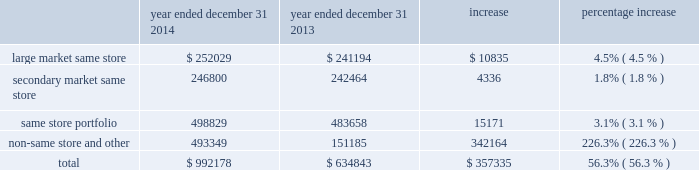Dispositions of depreciable real estate assets excluded from discontinued operations we recorded a gain on sale of depreciable assets excluded from discontinued operations of $ 190.0 million for the year ended december 31 , 2015 , an increase of approximately $ 147.3 million from the $ 42.6 million gain on sale of depreciable assets recorded for the year ended december 31 , 2014 .
The increase was primarily the result of increased disposition activity .
Dispositions increased from eight multifamily properties for the year ended december 31 , 2014 , to 21 multifamily properties for the year ended december 31 , 2015 .
Gain from real estate joint ventures we recorded a gain from real estate joint ventures of $ 6.0 million during the year ended december 31 , 2014 as opposed to no material gain or loss being recorded during the year ended december 31 , 2015 .
The decrease was primarily a result of recording a $ 3.4 million gain for the disposition of ansley village by mid-america multifamily fund ii , or fund ii , as well as a $ 2.8 million gain for the promote fee received from our fund ii partner during 2014 .
The promote fee was received as a result of maa achieving certain performance metrics in its management of the fund ii properties over the life of the joint venture .
There were no such gains recorded during the year ended december 31 , 2015 .
Discontinued operations we recorded a gain on sale of discontinued operations of $ 5.4 million for the year ended december 31 , 2014 .
We did not record a gain or loss on sale of discontinued operations during the year ended december 31 , 2015 , due to the adoption of asu 2014-08 , reporting discontinued operations and disclosures of disposals of components of an entity , which resulted in dispositions being included in the gain on sale of depreciable real estate assets excluded from discontinued operations and is discussed further below .
Net income attributable to noncontrolling interests net income attributable to noncontrolling interests for the year ended december 31 , 2015 was approximately $ 18.5 million , an increase of $ 10.2 million from the year ended december 31 , 2014 .
This increase is consistent with the increase to overall net income and is primarily a result of the items discussed above .
Net income attributable to maa primarily as a result of the items discussed above , net income attributable to maa increased by approximately $ 184.3 million in the year ended december 31 , 2015 from the year ended december 31 , 2014 .
Comparison of the year ended december 31 , 2014 to the year ended december 31 , 2013 the comparison of the year ended december 31 , 2014 to the year ended december 31 , 2013 shows the segment break down based on the 2014 same store portfolios .
A comparison using the 2015 same store portfolio would not be comparative due to the nature of the classifications as a result of the merger .
Property revenues the table shows our property revenues by segment for the years ended december 31 , 2014 and december 31 , 2013 ( dollars in thousands ) : year ended december 31 , 2014 year ended december 31 , 2013 increase percentage increase .
Job title mid-america apartment 10-k revision 1 serial <12345678> date sunday , march 20 , 2016 job number 304352-1 type page no .
51 operator abigaels .
What was the net income attributable to noncontrolling interests net income attributable to noncontrolling interests for the year ended december 31 , 2014 in million? 
Rationale: the net income attributable to noncontrolling interests net income attributable to noncontrolling interests for the year ended december 31 , 2014 was 8.2 million
Computations: (18.5 - 10.2)
Answer: 8.3. Dispositions of depreciable real estate assets excluded from discontinued operations we recorded a gain on sale of depreciable assets excluded from discontinued operations of $ 190.0 million for the year ended december 31 , 2015 , an increase of approximately $ 147.3 million from the $ 42.6 million gain on sale of depreciable assets recorded for the year ended december 31 , 2014 .
The increase was primarily the result of increased disposition activity .
Dispositions increased from eight multifamily properties for the year ended december 31 , 2014 , to 21 multifamily properties for the year ended december 31 , 2015 .
Gain from real estate joint ventures we recorded a gain from real estate joint ventures of $ 6.0 million during the year ended december 31 , 2014 as opposed to no material gain or loss being recorded during the year ended december 31 , 2015 .
The decrease was primarily a result of recording a $ 3.4 million gain for the disposition of ansley village by mid-america multifamily fund ii , or fund ii , as well as a $ 2.8 million gain for the promote fee received from our fund ii partner during 2014 .
The promote fee was received as a result of maa achieving certain performance metrics in its management of the fund ii properties over the life of the joint venture .
There were no such gains recorded during the year ended december 31 , 2015 .
Discontinued operations we recorded a gain on sale of discontinued operations of $ 5.4 million for the year ended december 31 , 2014 .
We did not record a gain or loss on sale of discontinued operations during the year ended december 31 , 2015 , due to the adoption of asu 2014-08 , reporting discontinued operations and disclosures of disposals of components of an entity , which resulted in dispositions being included in the gain on sale of depreciable real estate assets excluded from discontinued operations and is discussed further below .
Net income attributable to noncontrolling interests net income attributable to noncontrolling interests for the year ended december 31 , 2015 was approximately $ 18.5 million , an increase of $ 10.2 million from the year ended december 31 , 2014 .
This increase is consistent with the increase to overall net income and is primarily a result of the items discussed above .
Net income attributable to maa primarily as a result of the items discussed above , net income attributable to maa increased by approximately $ 184.3 million in the year ended december 31 , 2015 from the year ended december 31 , 2014 .
Comparison of the year ended december 31 , 2014 to the year ended december 31 , 2013 the comparison of the year ended december 31 , 2014 to the year ended december 31 , 2013 shows the segment break down based on the 2014 same store portfolios .
A comparison using the 2015 same store portfolio would not be comparative due to the nature of the classifications as a result of the merger .
Property revenues the table shows our property revenues by segment for the years ended december 31 , 2014 and december 31 , 2013 ( dollars in thousands ) : year ended december 31 , 2014 year ended december 31 , 2013 increase percentage increase .
Job title mid-america apartment 10-k revision 1 serial <12345678> date sunday , march 20 , 2016 job number 304352-1 type page no .
51 operator abigaels .
What is the variation observed in the percentual increase of the same store portfolio and the non-same store revenue during 2013 and 2014? 
Rationale: it is the difference between those percentages .
Computations: (226.3% - 3.1%)
Answer: 2.232. 